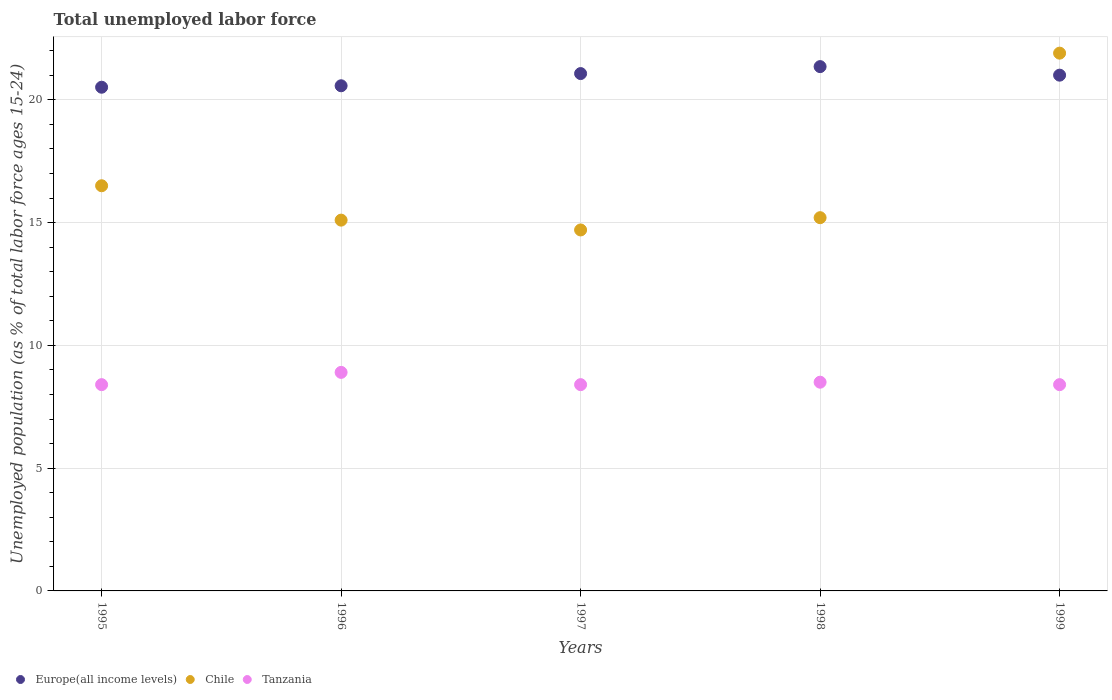How many different coloured dotlines are there?
Your answer should be compact. 3. What is the percentage of unemployed population in in Europe(all income levels) in 1999?
Your answer should be compact. 21. Across all years, what is the maximum percentage of unemployed population in in Europe(all income levels)?
Your answer should be very brief. 21.35. Across all years, what is the minimum percentage of unemployed population in in Tanzania?
Provide a succinct answer. 8.4. In which year was the percentage of unemployed population in in Chile minimum?
Ensure brevity in your answer.  1997. What is the total percentage of unemployed population in in Tanzania in the graph?
Offer a terse response. 42.6. What is the difference between the percentage of unemployed population in in Chile in 1998 and that in 1999?
Ensure brevity in your answer.  -6.7. What is the difference between the percentage of unemployed population in in Europe(all income levels) in 1998 and the percentage of unemployed population in in Tanzania in 1996?
Give a very brief answer. 12.45. What is the average percentage of unemployed population in in Chile per year?
Make the answer very short. 16.68. In the year 1996, what is the difference between the percentage of unemployed population in in Chile and percentage of unemployed population in in Europe(all income levels)?
Give a very brief answer. -5.47. In how many years, is the percentage of unemployed population in in Europe(all income levels) greater than 13 %?
Your answer should be compact. 5. What is the ratio of the percentage of unemployed population in in Chile in 1995 to that in 1997?
Your answer should be compact. 1.12. Is the difference between the percentage of unemployed population in in Chile in 1995 and 1997 greater than the difference between the percentage of unemployed population in in Europe(all income levels) in 1995 and 1997?
Ensure brevity in your answer.  Yes. What is the difference between the highest and the second highest percentage of unemployed population in in Europe(all income levels)?
Ensure brevity in your answer.  0.28. What is the difference between the highest and the lowest percentage of unemployed population in in Chile?
Give a very brief answer. 7.2. In how many years, is the percentage of unemployed population in in Chile greater than the average percentage of unemployed population in in Chile taken over all years?
Your answer should be compact. 1. Is the percentage of unemployed population in in Chile strictly greater than the percentage of unemployed population in in Tanzania over the years?
Your answer should be compact. Yes. Is the percentage of unemployed population in in Chile strictly less than the percentage of unemployed population in in Europe(all income levels) over the years?
Provide a short and direct response. No. How many years are there in the graph?
Your answer should be compact. 5. How many legend labels are there?
Provide a succinct answer. 3. How are the legend labels stacked?
Make the answer very short. Horizontal. What is the title of the graph?
Make the answer very short. Total unemployed labor force. What is the label or title of the Y-axis?
Your answer should be very brief. Unemployed population (as % of total labor force ages 15-24). What is the Unemployed population (as % of total labor force ages 15-24) of Europe(all income levels) in 1995?
Your answer should be compact. 20.51. What is the Unemployed population (as % of total labor force ages 15-24) of Chile in 1995?
Make the answer very short. 16.5. What is the Unemployed population (as % of total labor force ages 15-24) in Tanzania in 1995?
Offer a very short reply. 8.4. What is the Unemployed population (as % of total labor force ages 15-24) of Europe(all income levels) in 1996?
Offer a terse response. 20.57. What is the Unemployed population (as % of total labor force ages 15-24) in Chile in 1996?
Ensure brevity in your answer.  15.1. What is the Unemployed population (as % of total labor force ages 15-24) in Tanzania in 1996?
Ensure brevity in your answer.  8.9. What is the Unemployed population (as % of total labor force ages 15-24) in Europe(all income levels) in 1997?
Make the answer very short. 21.07. What is the Unemployed population (as % of total labor force ages 15-24) in Chile in 1997?
Your response must be concise. 14.7. What is the Unemployed population (as % of total labor force ages 15-24) in Tanzania in 1997?
Your answer should be compact. 8.4. What is the Unemployed population (as % of total labor force ages 15-24) of Europe(all income levels) in 1998?
Offer a terse response. 21.35. What is the Unemployed population (as % of total labor force ages 15-24) of Chile in 1998?
Offer a very short reply. 15.2. What is the Unemployed population (as % of total labor force ages 15-24) in Tanzania in 1998?
Provide a succinct answer. 8.5. What is the Unemployed population (as % of total labor force ages 15-24) in Europe(all income levels) in 1999?
Offer a very short reply. 21. What is the Unemployed population (as % of total labor force ages 15-24) of Chile in 1999?
Give a very brief answer. 21.9. What is the Unemployed population (as % of total labor force ages 15-24) in Tanzania in 1999?
Your response must be concise. 8.4. Across all years, what is the maximum Unemployed population (as % of total labor force ages 15-24) of Europe(all income levels)?
Make the answer very short. 21.35. Across all years, what is the maximum Unemployed population (as % of total labor force ages 15-24) in Chile?
Your response must be concise. 21.9. Across all years, what is the maximum Unemployed population (as % of total labor force ages 15-24) in Tanzania?
Your response must be concise. 8.9. Across all years, what is the minimum Unemployed population (as % of total labor force ages 15-24) of Europe(all income levels)?
Your response must be concise. 20.51. Across all years, what is the minimum Unemployed population (as % of total labor force ages 15-24) of Chile?
Your response must be concise. 14.7. Across all years, what is the minimum Unemployed population (as % of total labor force ages 15-24) in Tanzania?
Offer a very short reply. 8.4. What is the total Unemployed population (as % of total labor force ages 15-24) in Europe(all income levels) in the graph?
Ensure brevity in your answer.  104.51. What is the total Unemployed population (as % of total labor force ages 15-24) in Chile in the graph?
Make the answer very short. 83.4. What is the total Unemployed population (as % of total labor force ages 15-24) of Tanzania in the graph?
Provide a succinct answer. 42.6. What is the difference between the Unemployed population (as % of total labor force ages 15-24) of Europe(all income levels) in 1995 and that in 1996?
Provide a succinct answer. -0.06. What is the difference between the Unemployed population (as % of total labor force ages 15-24) of Chile in 1995 and that in 1996?
Provide a succinct answer. 1.4. What is the difference between the Unemployed population (as % of total labor force ages 15-24) in Tanzania in 1995 and that in 1996?
Your answer should be very brief. -0.5. What is the difference between the Unemployed population (as % of total labor force ages 15-24) of Europe(all income levels) in 1995 and that in 1997?
Offer a terse response. -0.56. What is the difference between the Unemployed population (as % of total labor force ages 15-24) in Tanzania in 1995 and that in 1997?
Ensure brevity in your answer.  0. What is the difference between the Unemployed population (as % of total labor force ages 15-24) in Europe(all income levels) in 1995 and that in 1998?
Provide a succinct answer. -0.84. What is the difference between the Unemployed population (as % of total labor force ages 15-24) of Chile in 1995 and that in 1998?
Offer a very short reply. 1.3. What is the difference between the Unemployed population (as % of total labor force ages 15-24) in Tanzania in 1995 and that in 1998?
Your answer should be compact. -0.1. What is the difference between the Unemployed population (as % of total labor force ages 15-24) in Europe(all income levels) in 1995 and that in 1999?
Provide a succinct answer. -0.49. What is the difference between the Unemployed population (as % of total labor force ages 15-24) of Chile in 1995 and that in 1999?
Provide a short and direct response. -5.4. What is the difference between the Unemployed population (as % of total labor force ages 15-24) of Tanzania in 1995 and that in 1999?
Provide a short and direct response. 0. What is the difference between the Unemployed population (as % of total labor force ages 15-24) in Europe(all income levels) in 1996 and that in 1997?
Your response must be concise. -0.5. What is the difference between the Unemployed population (as % of total labor force ages 15-24) in Tanzania in 1996 and that in 1997?
Provide a succinct answer. 0.5. What is the difference between the Unemployed population (as % of total labor force ages 15-24) in Europe(all income levels) in 1996 and that in 1998?
Provide a succinct answer. -0.78. What is the difference between the Unemployed population (as % of total labor force ages 15-24) in Europe(all income levels) in 1996 and that in 1999?
Offer a terse response. -0.43. What is the difference between the Unemployed population (as % of total labor force ages 15-24) in Chile in 1996 and that in 1999?
Your answer should be very brief. -6.8. What is the difference between the Unemployed population (as % of total labor force ages 15-24) of Europe(all income levels) in 1997 and that in 1998?
Your answer should be very brief. -0.28. What is the difference between the Unemployed population (as % of total labor force ages 15-24) of Europe(all income levels) in 1997 and that in 1999?
Provide a succinct answer. 0.06. What is the difference between the Unemployed population (as % of total labor force ages 15-24) of Europe(all income levels) in 1998 and that in 1999?
Keep it short and to the point. 0.35. What is the difference between the Unemployed population (as % of total labor force ages 15-24) of Chile in 1998 and that in 1999?
Your answer should be compact. -6.7. What is the difference between the Unemployed population (as % of total labor force ages 15-24) in Europe(all income levels) in 1995 and the Unemployed population (as % of total labor force ages 15-24) in Chile in 1996?
Your response must be concise. 5.41. What is the difference between the Unemployed population (as % of total labor force ages 15-24) of Europe(all income levels) in 1995 and the Unemployed population (as % of total labor force ages 15-24) of Tanzania in 1996?
Provide a short and direct response. 11.61. What is the difference between the Unemployed population (as % of total labor force ages 15-24) in Chile in 1995 and the Unemployed population (as % of total labor force ages 15-24) in Tanzania in 1996?
Provide a short and direct response. 7.6. What is the difference between the Unemployed population (as % of total labor force ages 15-24) of Europe(all income levels) in 1995 and the Unemployed population (as % of total labor force ages 15-24) of Chile in 1997?
Provide a short and direct response. 5.81. What is the difference between the Unemployed population (as % of total labor force ages 15-24) of Europe(all income levels) in 1995 and the Unemployed population (as % of total labor force ages 15-24) of Tanzania in 1997?
Your answer should be very brief. 12.11. What is the difference between the Unemployed population (as % of total labor force ages 15-24) in Europe(all income levels) in 1995 and the Unemployed population (as % of total labor force ages 15-24) in Chile in 1998?
Your response must be concise. 5.31. What is the difference between the Unemployed population (as % of total labor force ages 15-24) in Europe(all income levels) in 1995 and the Unemployed population (as % of total labor force ages 15-24) in Tanzania in 1998?
Provide a short and direct response. 12.01. What is the difference between the Unemployed population (as % of total labor force ages 15-24) of Europe(all income levels) in 1995 and the Unemployed population (as % of total labor force ages 15-24) of Chile in 1999?
Keep it short and to the point. -1.39. What is the difference between the Unemployed population (as % of total labor force ages 15-24) in Europe(all income levels) in 1995 and the Unemployed population (as % of total labor force ages 15-24) in Tanzania in 1999?
Ensure brevity in your answer.  12.11. What is the difference between the Unemployed population (as % of total labor force ages 15-24) of Chile in 1995 and the Unemployed population (as % of total labor force ages 15-24) of Tanzania in 1999?
Make the answer very short. 8.1. What is the difference between the Unemployed population (as % of total labor force ages 15-24) in Europe(all income levels) in 1996 and the Unemployed population (as % of total labor force ages 15-24) in Chile in 1997?
Offer a very short reply. 5.87. What is the difference between the Unemployed population (as % of total labor force ages 15-24) of Europe(all income levels) in 1996 and the Unemployed population (as % of total labor force ages 15-24) of Tanzania in 1997?
Your answer should be compact. 12.17. What is the difference between the Unemployed population (as % of total labor force ages 15-24) in Chile in 1996 and the Unemployed population (as % of total labor force ages 15-24) in Tanzania in 1997?
Ensure brevity in your answer.  6.7. What is the difference between the Unemployed population (as % of total labor force ages 15-24) of Europe(all income levels) in 1996 and the Unemployed population (as % of total labor force ages 15-24) of Chile in 1998?
Make the answer very short. 5.37. What is the difference between the Unemployed population (as % of total labor force ages 15-24) in Europe(all income levels) in 1996 and the Unemployed population (as % of total labor force ages 15-24) in Tanzania in 1998?
Give a very brief answer. 12.07. What is the difference between the Unemployed population (as % of total labor force ages 15-24) in Europe(all income levels) in 1996 and the Unemployed population (as % of total labor force ages 15-24) in Chile in 1999?
Provide a succinct answer. -1.33. What is the difference between the Unemployed population (as % of total labor force ages 15-24) in Europe(all income levels) in 1996 and the Unemployed population (as % of total labor force ages 15-24) in Tanzania in 1999?
Provide a succinct answer. 12.17. What is the difference between the Unemployed population (as % of total labor force ages 15-24) of Chile in 1996 and the Unemployed population (as % of total labor force ages 15-24) of Tanzania in 1999?
Your answer should be compact. 6.7. What is the difference between the Unemployed population (as % of total labor force ages 15-24) of Europe(all income levels) in 1997 and the Unemployed population (as % of total labor force ages 15-24) of Chile in 1998?
Your answer should be compact. 5.87. What is the difference between the Unemployed population (as % of total labor force ages 15-24) of Europe(all income levels) in 1997 and the Unemployed population (as % of total labor force ages 15-24) of Tanzania in 1998?
Give a very brief answer. 12.57. What is the difference between the Unemployed population (as % of total labor force ages 15-24) in Chile in 1997 and the Unemployed population (as % of total labor force ages 15-24) in Tanzania in 1998?
Make the answer very short. 6.2. What is the difference between the Unemployed population (as % of total labor force ages 15-24) of Europe(all income levels) in 1997 and the Unemployed population (as % of total labor force ages 15-24) of Chile in 1999?
Your answer should be very brief. -0.83. What is the difference between the Unemployed population (as % of total labor force ages 15-24) in Europe(all income levels) in 1997 and the Unemployed population (as % of total labor force ages 15-24) in Tanzania in 1999?
Ensure brevity in your answer.  12.67. What is the difference between the Unemployed population (as % of total labor force ages 15-24) in Chile in 1997 and the Unemployed population (as % of total labor force ages 15-24) in Tanzania in 1999?
Your answer should be very brief. 6.3. What is the difference between the Unemployed population (as % of total labor force ages 15-24) of Europe(all income levels) in 1998 and the Unemployed population (as % of total labor force ages 15-24) of Chile in 1999?
Make the answer very short. -0.55. What is the difference between the Unemployed population (as % of total labor force ages 15-24) in Europe(all income levels) in 1998 and the Unemployed population (as % of total labor force ages 15-24) in Tanzania in 1999?
Give a very brief answer. 12.95. What is the difference between the Unemployed population (as % of total labor force ages 15-24) of Chile in 1998 and the Unemployed population (as % of total labor force ages 15-24) of Tanzania in 1999?
Provide a short and direct response. 6.8. What is the average Unemployed population (as % of total labor force ages 15-24) of Europe(all income levels) per year?
Ensure brevity in your answer.  20.9. What is the average Unemployed population (as % of total labor force ages 15-24) in Chile per year?
Give a very brief answer. 16.68. What is the average Unemployed population (as % of total labor force ages 15-24) in Tanzania per year?
Provide a succinct answer. 8.52. In the year 1995, what is the difference between the Unemployed population (as % of total labor force ages 15-24) of Europe(all income levels) and Unemployed population (as % of total labor force ages 15-24) of Chile?
Ensure brevity in your answer.  4.01. In the year 1995, what is the difference between the Unemployed population (as % of total labor force ages 15-24) in Europe(all income levels) and Unemployed population (as % of total labor force ages 15-24) in Tanzania?
Offer a terse response. 12.11. In the year 1996, what is the difference between the Unemployed population (as % of total labor force ages 15-24) of Europe(all income levels) and Unemployed population (as % of total labor force ages 15-24) of Chile?
Your answer should be very brief. 5.47. In the year 1996, what is the difference between the Unemployed population (as % of total labor force ages 15-24) of Europe(all income levels) and Unemployed population (as % of total labor force ages 15-24) of Tanzania?
Offer a terse response. 11.67. In the year 1996, what is the difference between the Unemployed population (as % of total labor force ages 15-24) in Chile and Unemployed population (as % of total labor force ages 15-24) in Tanzania?
Make the answer very short. 6.2. In the year 1997, what is the difference between the Unemployed population (as % of total labor force ages 15-24) in Europe(all income levels) and Unemployed population (as % of total labor force ages 15-24) in Chile?
Your answer should be very brief. 6.37. In the year 1997, what is the difference between the Unemployed population (as % of total labor force ages 15-24) in Europe(all income levels) and Unemployed population (as % of total labor force ages 15-24) in Tanzania?
Provide a short and direct response. 12.67. In the year 1997, what is the difference between the Unemployed population (as % of total labor force ages 15-24) of Chile and Unemployed population (as % of total labor force ages 15-24) of Tanzania?
Provide a short and direct response. 6.3. In the year 1998, what is the difference between the Unemployed population (as % of total labor force ages 15-24) in Europe(all income levels) and Unemployed population (as % of total labor force ages 15-24) in Chile?
Your answer should be compact. 6.15. In the year 1998, what is the difference between the Unemployed population (as % of total labor force ages 15-24) in Europe(all income levels) and Unemployed population (as % of total labor force ages 15-24) in Tanzania?
Your answer should be compact. 12.85. In the year 1998, what is the difference between the Unemployed population (as % of total labor force ages 15-24) of Chile and Unemployed population (as % of total labor force ages 15-24) of Tanzania?
Keep it short and to the point. 6.7. In the year 1999, what is the difference between the Unemployed population (as % of total labor force ages 15-24) of Europe(all income levels) and Unemployed population (as % of total labor force ages 15-24) of Chile?
Your response must be concise. -0.9. In the year 1999, what is the difference between the Unemployed population (as % of total labor force ages 15-24) of Europe(all income levels) and Unemployed population (as % of total labor force ages 15-24) of Tanzania?
Provide a succinct answer. 12.6. What is the ratio of the Unemployed population (as % of total labor force ages 15-24) in Europe(all income levels) in 1995 to that in 1996?
Give a very brief answer. 1. What is the ratio of the Unemployed population (as % of total labor force ages 15-24) of Chile in 1995 to that in 1996?
Offer a terse response. 1.09. What is the ratio of the Unemployed population (as % of total labor force ages 15-24) of Tanzania in 1995 to that in 1996?
Provide a short and direct response. 0.94. What is the ratio of the Unemployed population (as % of total labor force ages 15-24) in Europe(all income levels) in 1995 to that in 1997?
Keep it short and to the point. 0.97. What is the ratio of the Unemployed population (as % of total labor force ages 15-24) in Chile in 1995 to that in 1997?
Keep it short and to the point. 1.12. What is the ratio of the Unemployed population (as % of total labor force ages 15-24) of Europe(all income levels) in 1995 to that in 1998?
Ensure brevity in your answer.  0.96. What is the ratio of the Unemployed population (as % of total labor force ages 15-24) in Chile in 1995 to that in 1998?
Your response must be concise. 1.09. What is the ratio of the Unemployed population (as % of total labor force ages 15-24) in Europe(all income levels) in 1995 to that in 1999?
Provide a short and direct response. 0.98. What is the ratio of the Unemployed population (as % of total labor force ages 15-24) in Chile in 1995 to that in 1999?
Provide a succinct answer. 0.75. What is the ratio of the Unemployed population (as % of total labor force ages 15-24) in Tanzania in 1995 to that in 1999?
Your answer should be very brief. 1. What is the ratio of the Unemployed population (as % of total labor force ages 15-24) of Europe(all income levels) in 1996 to that in 1997?
Offer a terse response. 0.98. What is the ratio of the Unemployed population (as % of total labor force ages 15-24) in Chile in 1996 to that in 1997?
Your response must be concise. 1.03. What is the ratio of the Unemployed population (as % of total labor force ages 15-24) of Tanzania in 1996 to that in 1997?
Provide a succinct answer. 1.06. What is the ratio of the Unemployed population (as % of total labor force ages 15-24) of Europe(all income levels) in 1996 to that in 1998?
Keep it short and to the point. 0.96. What is the ratio of the Unemployed population (as % of total labor force ages 15-24) of Chile in 1996 to that in 1998?
Provide a short and direct response. 0.99. What is the ratio of the Unemployed population (as % of total labor force ages 15-24) of Tanzania in 1996 to that in 1998?
Your answer should be very brief. 1.05. What is the ratio of the Unemployed population (as % of total labor force ages 15-24) of Europe(all income levels) in 1996 to that in 1999?
Offer a very short reply. 0.98. What is the ratio of the Unemployed population (as % of total labor force ages 15-24) of Chile in 1996 to that in 1999?
Offer a terse response. 0.69. What is the ratio of the Unemployed population (as % of total labor force ages 15-24) in Tanzania in 1996 to that in 1999?
Provide a succinct answer. 1.06. What is the ratio of the Unemployed population (as % of total labor force ages 15-24) of Europe(all income levels) in 1997 to that in 1998?
Offer a terse response. 0.99. What is the ratio of the Unemployed population (as % of total labor force ages 15-24) of Chile in 1997 to that in 1998?
Make the answer very short. 0.97. What is the ratio of the Unemployed population (as % of total labor force ages 15-24) of Chile in 1997 to that in 1999?
Ensure brevity in your answer.  0.67. What is the ratio of the Unemployed population (as % of total labor force ages 15-24) in Europe(all income levels) in 1998 to that in 1999?
Provide a succinct answer. 1.02. What is the ratio of the Unemployed population (as % of total labor force ages 15-24) of Chile in 1998 to that in 1999?
Provide a short and direct response. 0.69. What is the ratio of the Unemployed population (as % of total labor force ages 15-24) in Tanzania in 1998 to that in 1999?
Offer a terse response. 1.01. What is the difference between the highest and the second highest Unemployed population (as % of total labor force ages 15-24) of Europe(all income levels)?
Offer a terse response. 0.28. What is the difference between the highest and the second highest Unemployed population (as % of total labor force ages 15-24) in Tanzania?
Offer a very short reply. 0.4. What is the difference between the highest and the lowest Unemployed population (as % of total labor force ages 15-24) of Europe(all income levels)?
Provide a succinct answer. 0.84. 